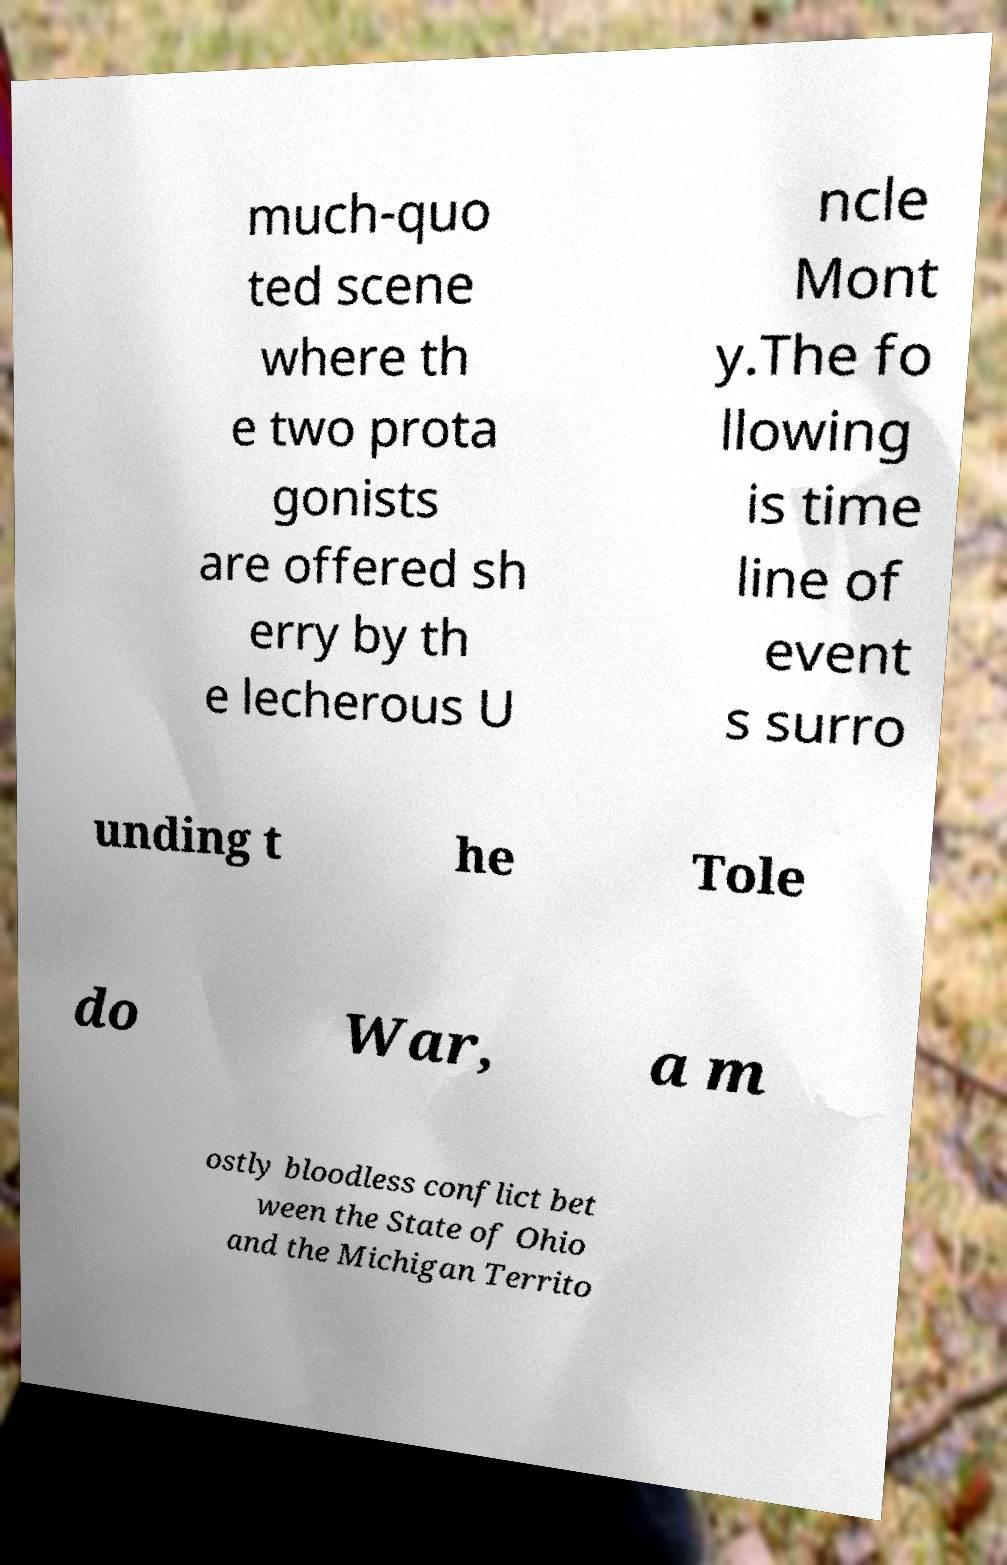Please identify and transcribe the text found in this image. much-quo ted scene where th e two prota gonists are offered sh erry by th e lecherous U ncle Mont y.The fo llowing is time line of event s surro unding t he Tole do War, a m ostly bloodless conflict bet ween the State of Ohio and the Michigan Territo 